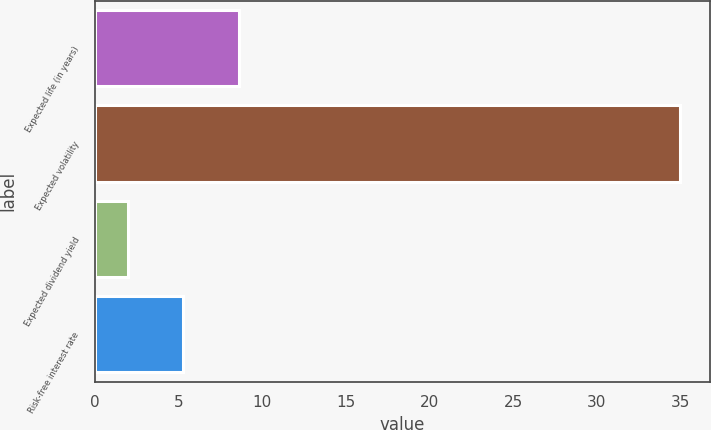Convert chart to OTSL. <chart><loc_0><loc_0><loc_500><loc_500><bar_chart><fcel>Expected life (in years)<fcel>Expected volatility<fcel>Expected dividend yield<fcel>Risk-free interest rate<nl><fcel>8.6<fcel>35<fcel>2<fcel>5.3<nl></chart> 